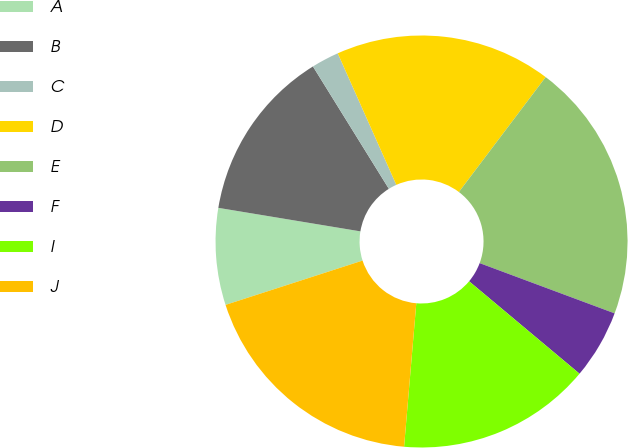Convert chart. <chart><loc_0><loc_0><loc_500><loc_500><pie_chart><fcel>A<fcel>B<fcel>C<fcel>D<fcel>E<fcel>F<fcel>I<fcel>J<nl><fcel>7.59%<fcel>13.55%<fcel>2.17%<fcel>16.96%<fcel>20.38%<fcel>5.42%<fcel>15.26%<fcel>18.67%<nl></chart> 